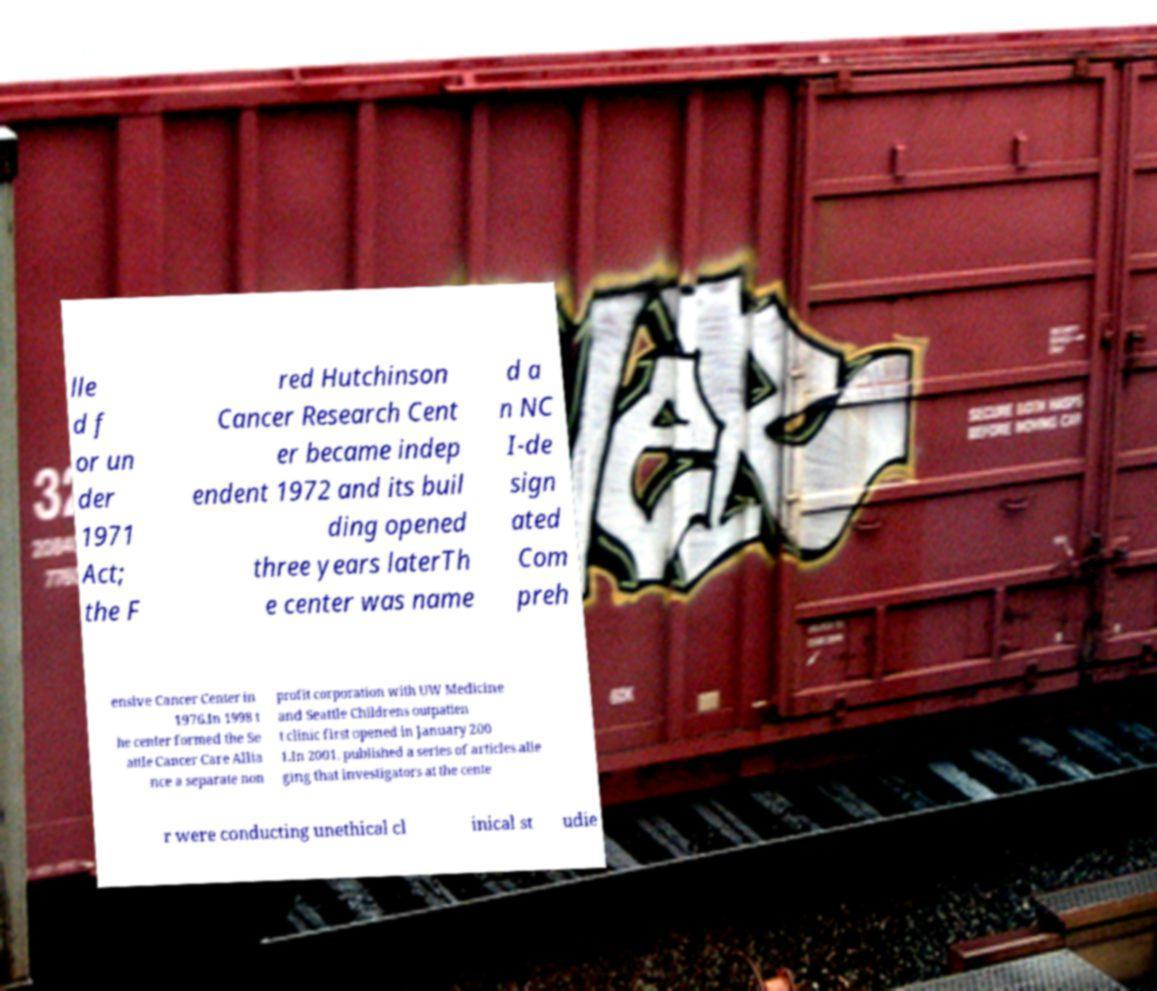I need the written content from this picture converted into text. Can you do that? lle d f or un der 1971 Act; the F red Hutchinson Cancer Research Cent er became indep endent 1972 and its buil ding opened three years laterTh e center was name d a n NC I-de sign ated Com preh ensive Cancer Center in 1976.In 1998 t he center formed the Se attle Cancer Care Allia nce a separate non profit corporation with UW Medicine and Seattle Childrens outpatien t clinic first opened in January 200 1.In 2001, published a series of articles alle ging that investigators at the cente r were conducting unethical cl inical st udie 